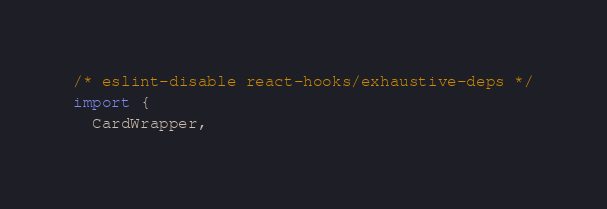<code> <loc_0><loc_0><loc_500><loc_500><_TypeScript_>/* eslint-disable react-hooks/exhaustive-deps */
import {
  CardWrapper,</code> 